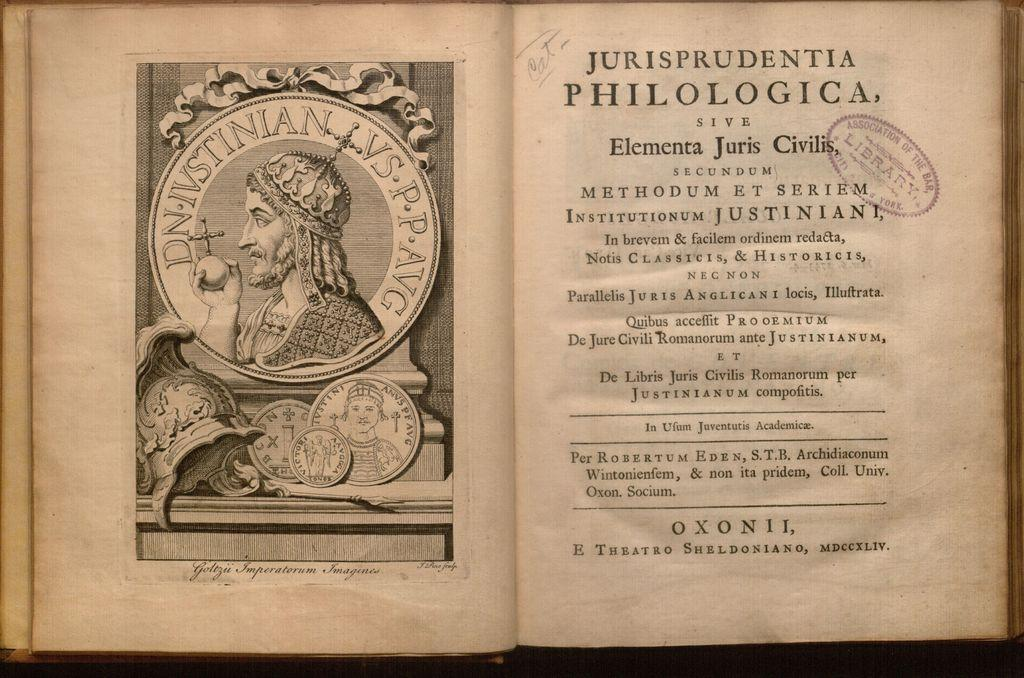<image>
Create a compact narrative representing the image presented. The word OxonII, can be seen at the bottom of this antique book 